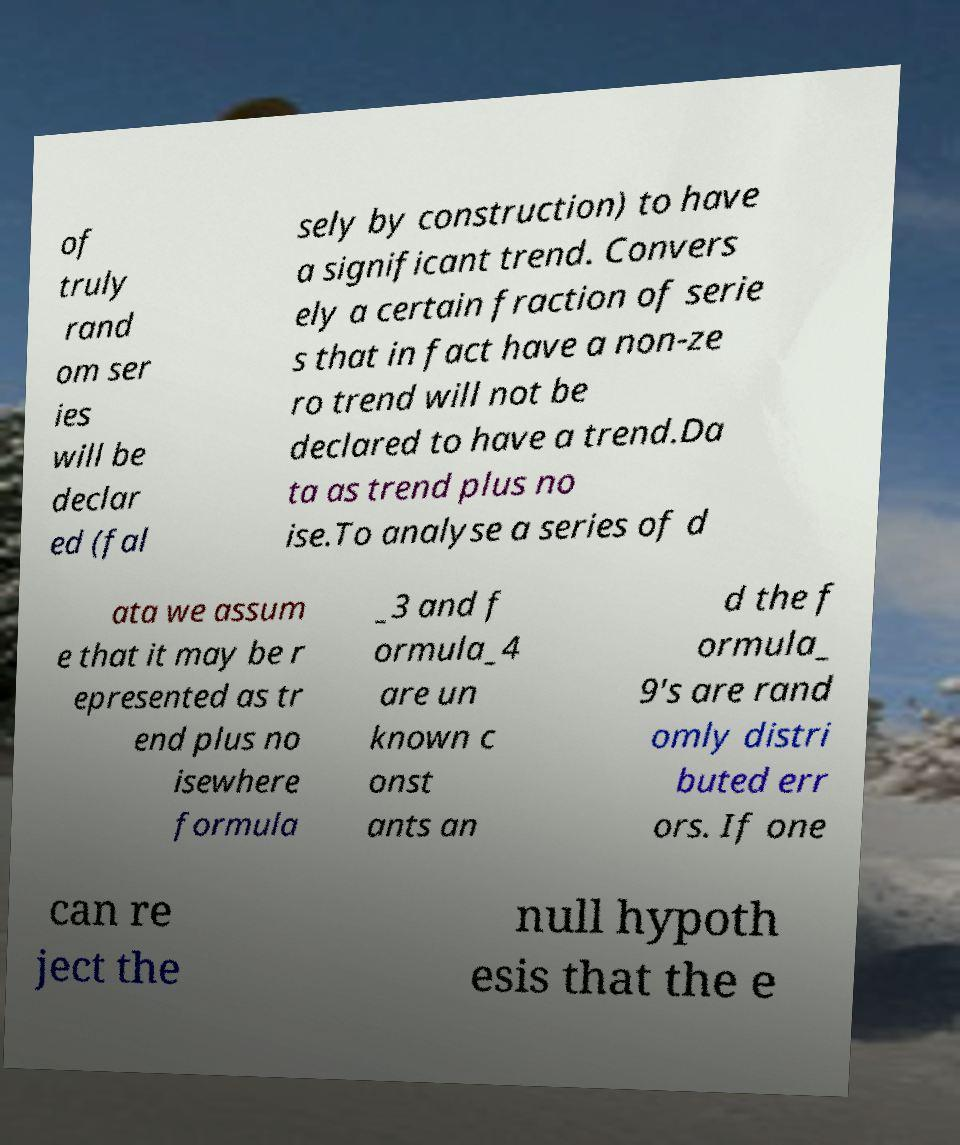What messages or text are displayed in this image? I need them in a readable, typed format. of truly rand om ser ies will be declar ed (fal sely by construction) to have a significant trend. Convers ely a certain fraction of serie s that in fact have a non-ze ro trend will not be declared to have a trend.Da ta as trend plus no ise.To analyse a series of d ata we assum e that it may be r epresented as tr end plus no isewhere formula _3 and f ormula_4 are un known c onst ants an d the f ormula_ 9's are rand omly distri buted err ors. If one can re ject the null hypoth esis that the e 